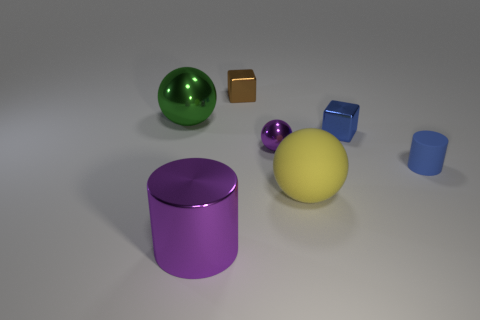Subtract all large spheres. How many spheres are left? 1 Subtract all green balls. How many balls are left? 2 Add 3 yellow balls. How many objects exist? 10 Subtract all balls. How many objects are left? 4 Subtract all gray cylinders. Subtract all blue cubes. How many cylinders are left? 2 Add 7 purple shiny spheres. How many purple shiny spheres are left? 8 Add 1 blocks. How many blocks exist? 3 Subtract 0 brown spheres. How many objects are left? 7 Subtract all blocks. Subtract all yellow rubber objects. How many objects are left? 4 